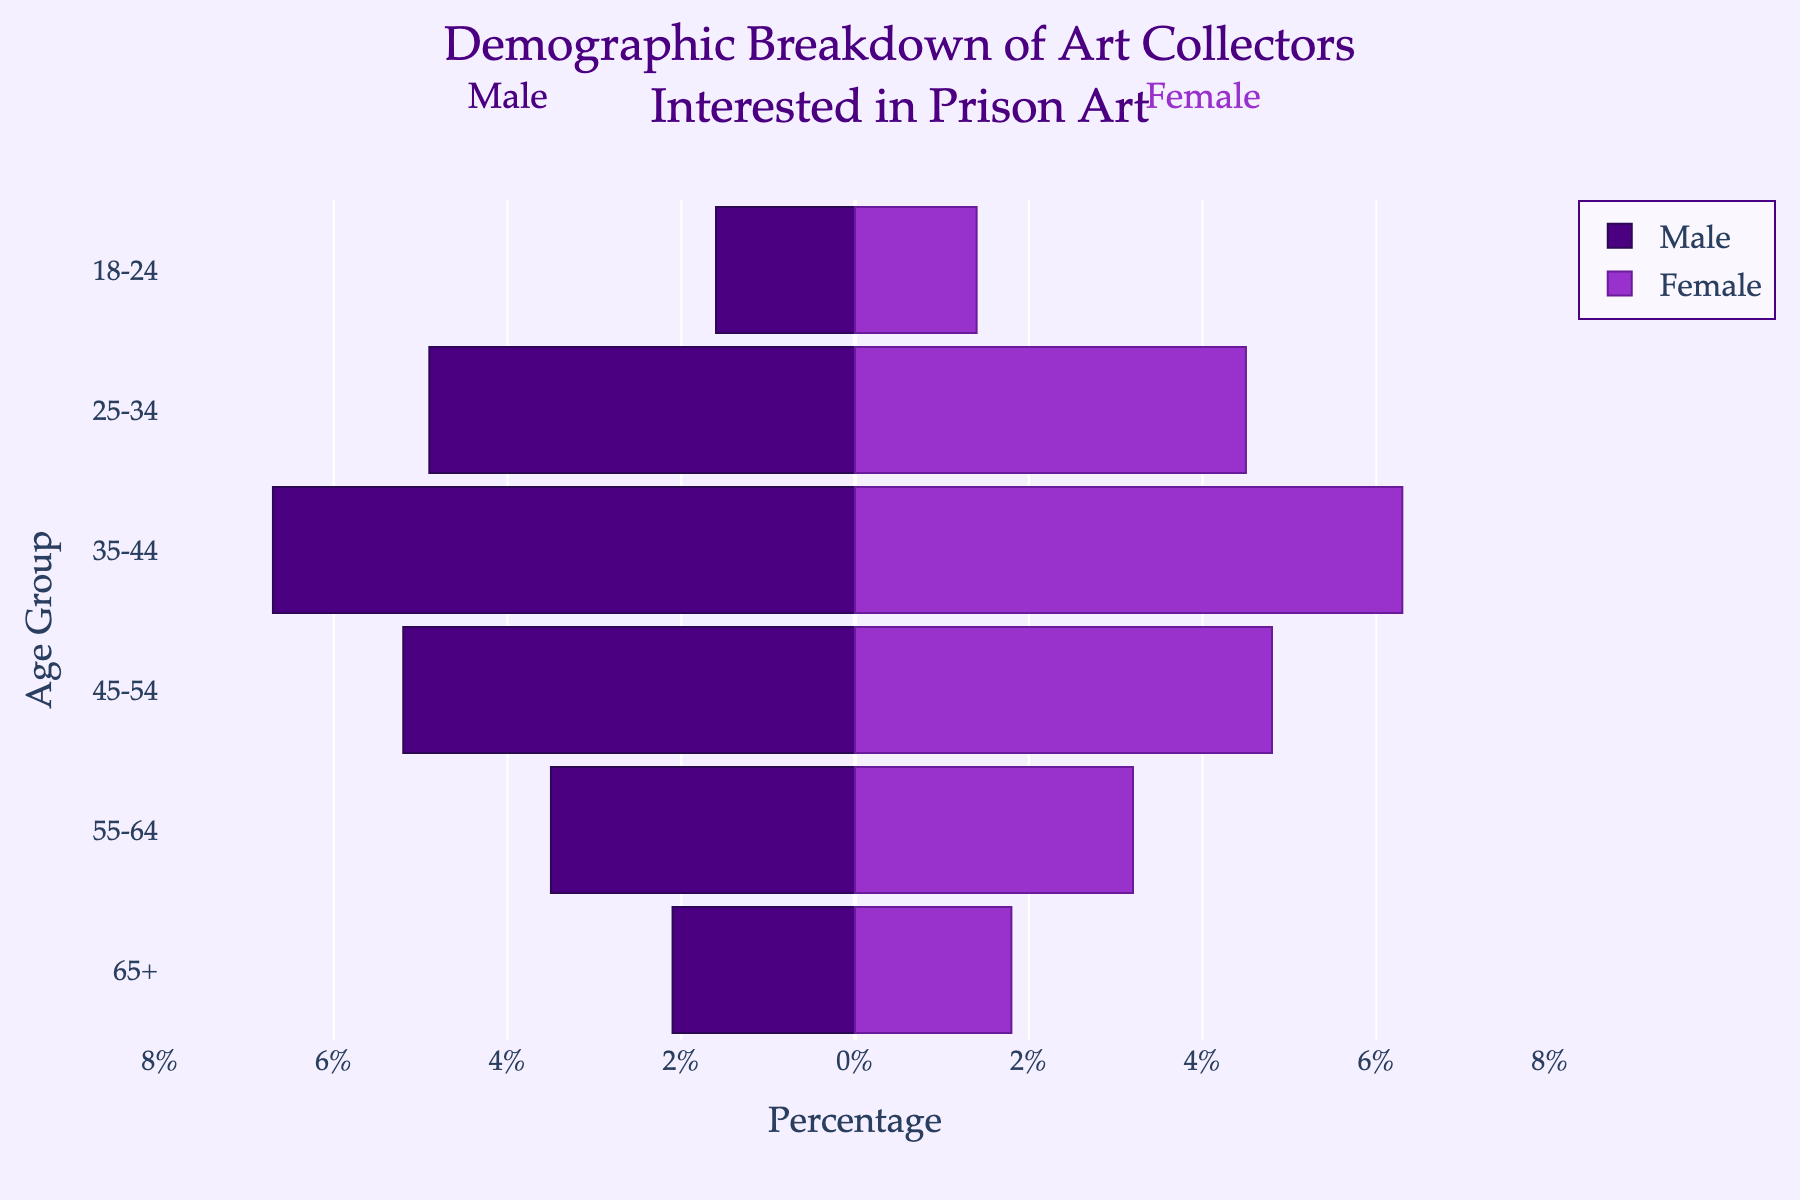What is the age group with the highest percentage of male collectors? The bars on the left side of the pyramid represent male collectors. The longest bar is in the '35-44' age group, indicating this group has the highest percentage.
Answer: 35-44 What is the title of the figure? The title is typically located at the top of the figure. In this case, it reads "Demographic Breakdown of Art Collectors Interested in Prison Art".
Answer: Demographic Breakdown of Art Collectors Interested in Prison Art What is the percentage difference between male and female collectors in the 25-34 age group? For males, the bar is at -4.9%, and for females, the bar is at 4.5%. Calculate the absolute difference:
Answer: 0.4% Which gender has a higher percentage in the 45-54 age group, and by how much? Compare the lengths of the bars for the '45-54' age group. Males are at -5.2%, and females are at 4.8%. Thus, males have a higher percentage.
Answer: Male by 0.4% What is the percentage of female collectors in the 18-24 age group? Locate the bar for the 18-24 age group on the right side, which represents female collectors. The length is 1.4%.
Answer: 1.4% What are the colors representing male and female collectors in the chart? The bars for males are colored in a shade of purple, while the bars for females are in a different shade of purple.
Answer: Shades of purple What is the total percentage of collectors aged 18-24 years old for both genders? Sum the percentages for both males and females in this age group: 1.6% (male) + 1.4% (female).
Answer: 3.0% How does the percentage of male collectors in the 65+ age group compare to the female collectors in the same group? The 65+ age group bars show 2.1% for males and 1.8% for females. The percentage for males is higher.
Answer: Males have 0.3% more What is the age group with the smallest percentage of male collectors? The shortest left-side bar corresponds to the 18-24 age group, which has a length of 1.6%.
Answer: 18-24 Is there an age group where the percentage of male and female collectors is equal? No bars in the figure for any age group are of equal length for both males and females. Therefore, there is no age group with equal percentages.
Answer: No 